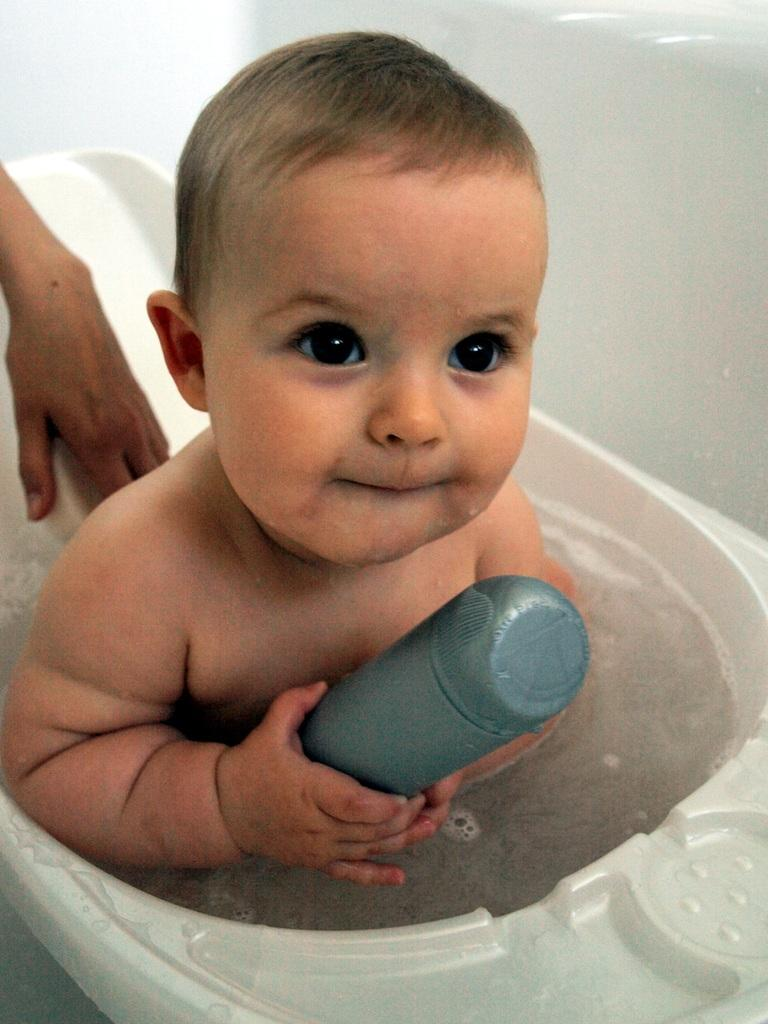What is the main subject of the image? A: There is a baby in the image. Where is the baby located? The baby is in a bathtub. What is the baby holding? The baby is holding an object. What can be seen in the background of the image? There is a wall in the background of the image, and a person's hand is visible. What type of shade is covering the baby in the image? There is no shade covering the baby in the image; the baby is in a bathtub. 